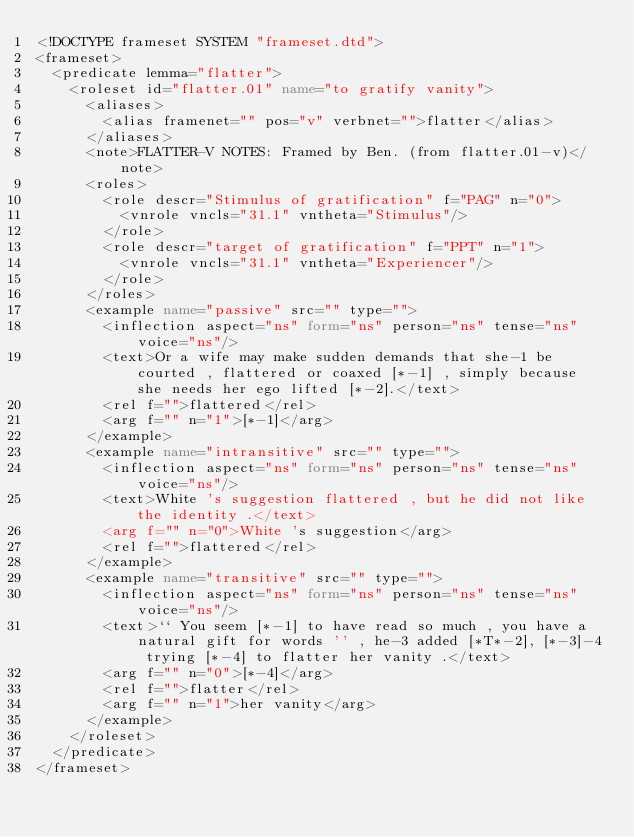<code> <loc_0><loc_0><loc_500><loc_500><_XML_><!DOCTYPE frameset SYSTEM "frameset.dtd">
<frameset>
  <predicate lemma="flatter">
    <roleset id="flatter.01" name="to gratify vanity">
      <aliases>
        <alias framenet="" pos="v" verbnet="">flatter</alias>
      </aliases>
      <note>FLATTER-V NOTES: Framed by Ben. (from flatter.01-v)</note>
      <roles>
        <role descr="Stimulus of gratification" f="PAG" n="0">
          <vnrole vncls="31.1" vntheta="Stimulus"/>
        </role>
        <role descr="target of gratification" f="PPT" n="1">
          <vnrole vncls="31.1" vntheta="Experiencer"/>
        </role>
      </roles>
      <example name="passive" src="" type="">
        <inflection aspect="ns" form="ns" person="ns" tense="ns" voice="ns"/>
        <text>Or a wife may make sudden demands that she-1 be courted , flattered or coaxed [*-1] , simply because she needs her ego lifted [*-2].</text>
        <rel f="">flattered</rel>
        <arg f="" n="1">[*-1]</arg>
      </example>
      <example name="intransitive" src="" type="">
        <inflection aspect="ns" form="ns" person="ns" tense="ns" voice="ns"/>
        <text>White 's suggestion flattered , but he did not like the identity .</text>
        <arg f="" n="0">White 's suggestion</arg>
        <rel f="">flattered</rel>
      </example>
      <example name="transitive" src="" type="">
        <inflection aspect="ns" form="ns" person="ns" tense="ns" voice="ns"/>
        <text>`` You seem [*-1] to have read so much , you have a natural gift for words '' , he-3 added [*T*-2], [*-3]-4 trying [*-4] to flatter her vanity .</text>
        <arg f="" n="0">[*-4]</arg>
        <rel f="">flatter</rel>
        <arg f="" n="1">her vanity</arg>
      </example>
    </roleset>
  </predicate>
</frameset>
</code> 